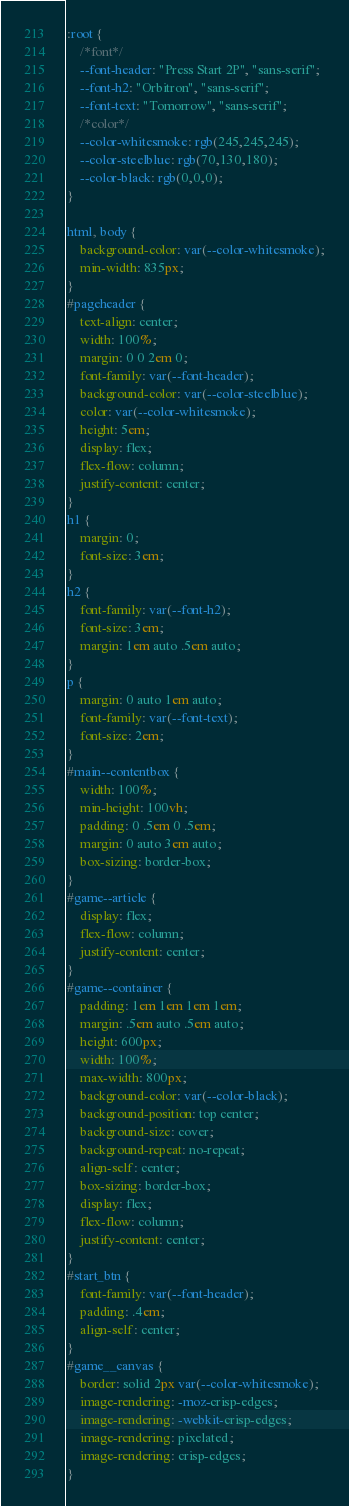Convert code to text. <code><loc_0><loc_0><loc_500><loc_500><_CSS_>:root {
	/*font*/
	--font-header: "Press Start 2P", "sans-serif";
	--font-h2: "Orbitron", "sans-serif";
	--font-text: "Tomorrow", "sans-serif";
	/*color*/
	--color-whitesmoke: rgb(245,245,245);
	--color-steelblue: rgb(70,130,180);
	--color-black: rgb(0,0,0);
}

html, body {
	background-color: var(--color-whitesmoke);
	min-width: 835px;
}
#pageheader {
	text-align: center;
	width: 100%;
	margin: 0 0 2em 0;
	font-family: var(--font-header);
	background-color: var(--color-steelblue);
	color: var(--color-whitesmoke);
	height: 5em;
	display: flex;
	flex-flow: column;
	justify-content: center;
}
h1 {
	margin: 0;
	font-size: 3em;
}
h2 {
	font-family: var(--font-h2);
	font-size: 3em;
	margin: 1em auto .5em auto;
}
p {
	margin: 0 auto 1em auto;
	font-family: var(--font-text);
	font-size: 2em;
}
#main--contentbox {
	width: 100%;
	min-height: 100vh;
	padding: 0 .5em 0 .5em;
	margin: 0 auto 3em auto;
	box-sizing: border-box;
}
#game--article {
	display: flex;
	flex-flow: column;
	justify-content: center;
}
#game--container {
	padding: 1em 1em 1em 1em;
	margin: .5em auto .5em auto;
	height: 600px;
	width: 100%;
	max-width: 800px;
	background-color: var(--color-black);
	background-position: top center;
	background-size: cover;
	background-repeat: no-repeat;
	align-self: center;
	box-sizing: border-box;
	display: flex;
	flex-flow: column;
	justify-content: center;
}
#start_btn {
	font-family: var(--font-header);
	padding: .4em;
	align-self: center;
}
#game__canvas {
	border: solid 2px var(--color-whitesmoke);
	image-rendering: -moz-crisp-edges;
  	image-rendering: -webkit-crisp-edges;
  	image-rendering: pixelated;
  	image-rendering: crisp-edges;
}</code> 